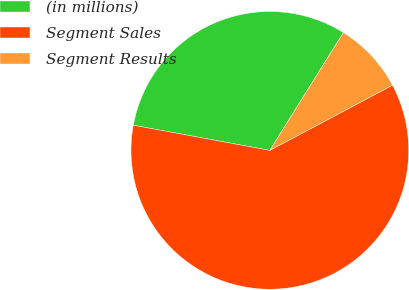Convert chart to OTSL. <chart><loc_0><loc_0><loc_500><loc_500><pie_chart><fcel>(in millions)<fcel>Segment Sales<fcel>Segment Results<nl><fcel>30.99%<fcel>60.67%<fcel>8.34%<nl></chart> 